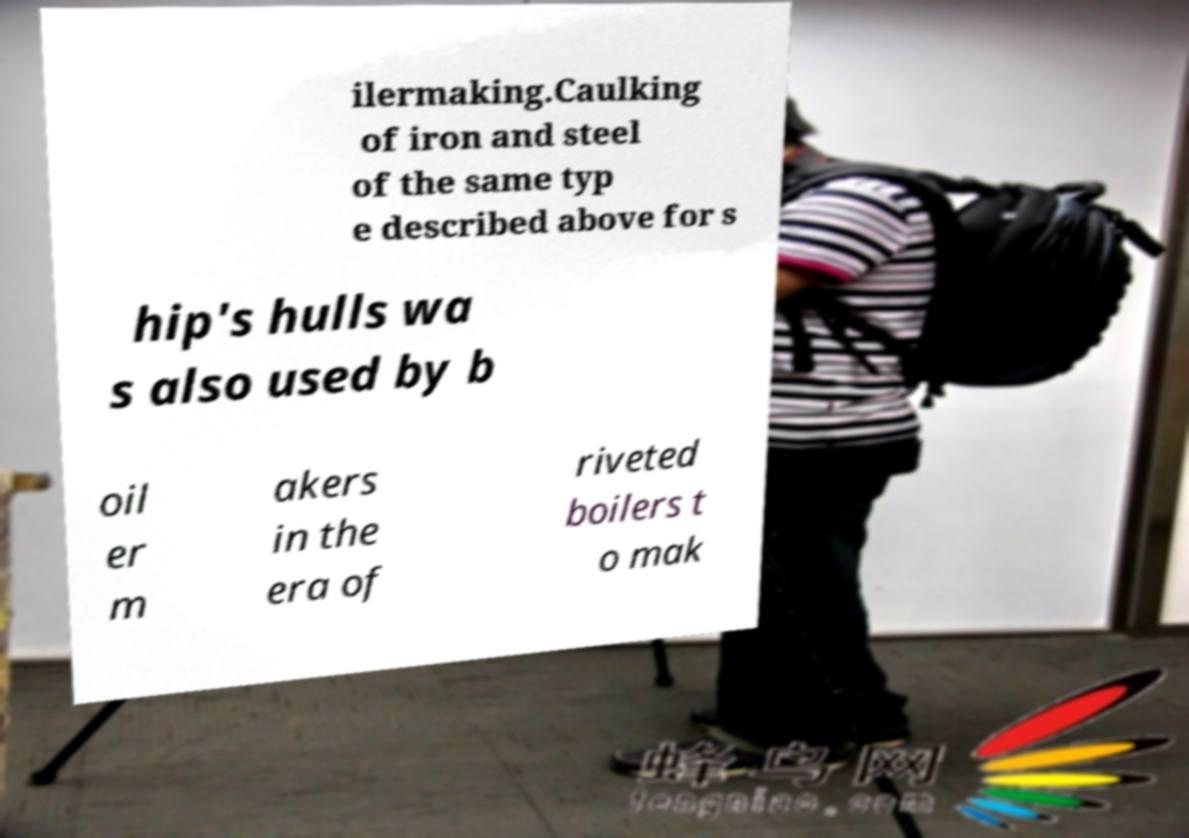Can you read and provide the text displayed in the image?This photo seems to have some interesting text. Can you extract and type it out for me? ilermaking.Caulking of iron and steel of the same typ e described above for s hip's hulls wa s also used by b oil er m akers in the era of riveted boilers t o mak 